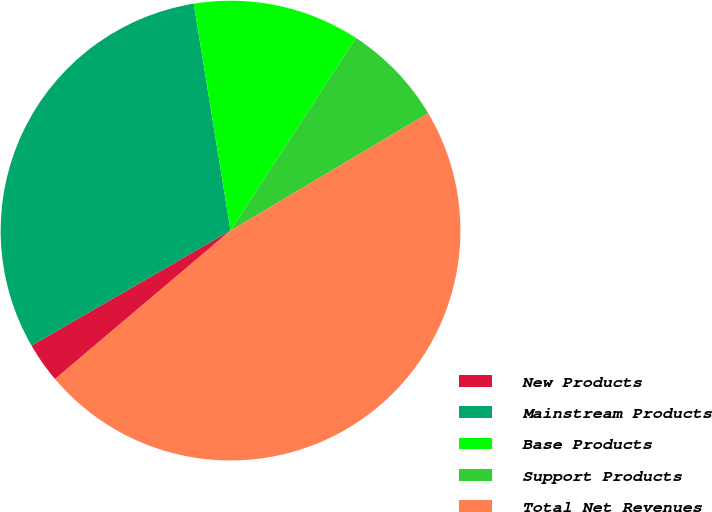<chart> <loc_0><loc_0><loc_500><loc_500><pie_chart><fcel>New Products<fcel>Mainstream Products<fcel>Base Products<fcel>Support Products<fcel>Total Net Revenues<nl><fcel>2.84%<fcel>30.78%<fcel>11.74%<fcel>7.29%<fcel>47.35%<nl></chart> 